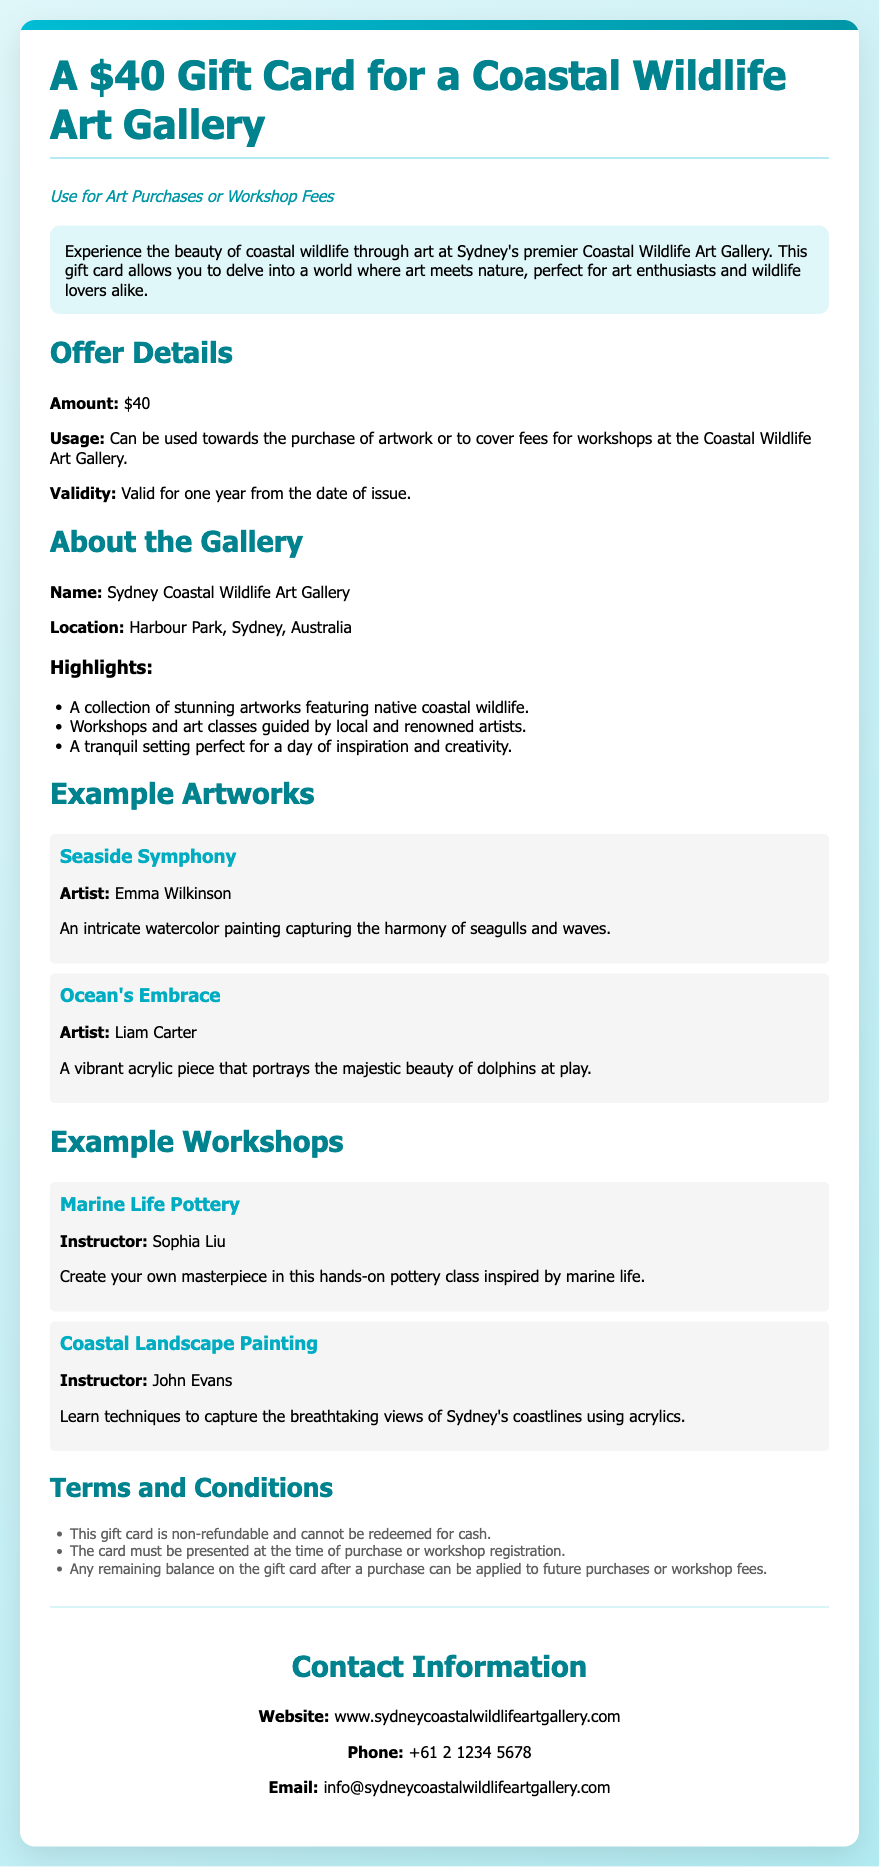What is the amount of the gift card? The document states the gift card amount is $40.
Answer: $40 Where is the Coastal Wildlife Art Gallery located? According to the document, the gallery is located at Harbour Park, Sydney, Australia.
Answer: Harbour Park, Sydney, Australia What types of uses does the gift card allow? The document mentions that the gift card can be used for art purchases or workshop fees.
Answer: Art purchases or workshop fees What is the validity period of the gift card? The document specifies that the gift card is valid for one year from the date of issue.
Answer: One year Who is the artist of "Seaside Symphony"? The document lists Emma Wilkinson as the artist of the artwork "Seaside Symphony."
Answer: Emma Wilkinson What type of workshop is "Marine Life Pottery"? The document describes this workshop as a hands-on pottery class inspired by marine life.
Answer: Hands-on pottery class Is the gift card refundable? The terms state that the gift card is non-refundable and cannot be redeemed for cash.
Answer: Non-refundable What must be presented at the time of purchase? The document specifies that the gift card must be presented at the time of purchase or workshop registration.
Answer: The gift card 